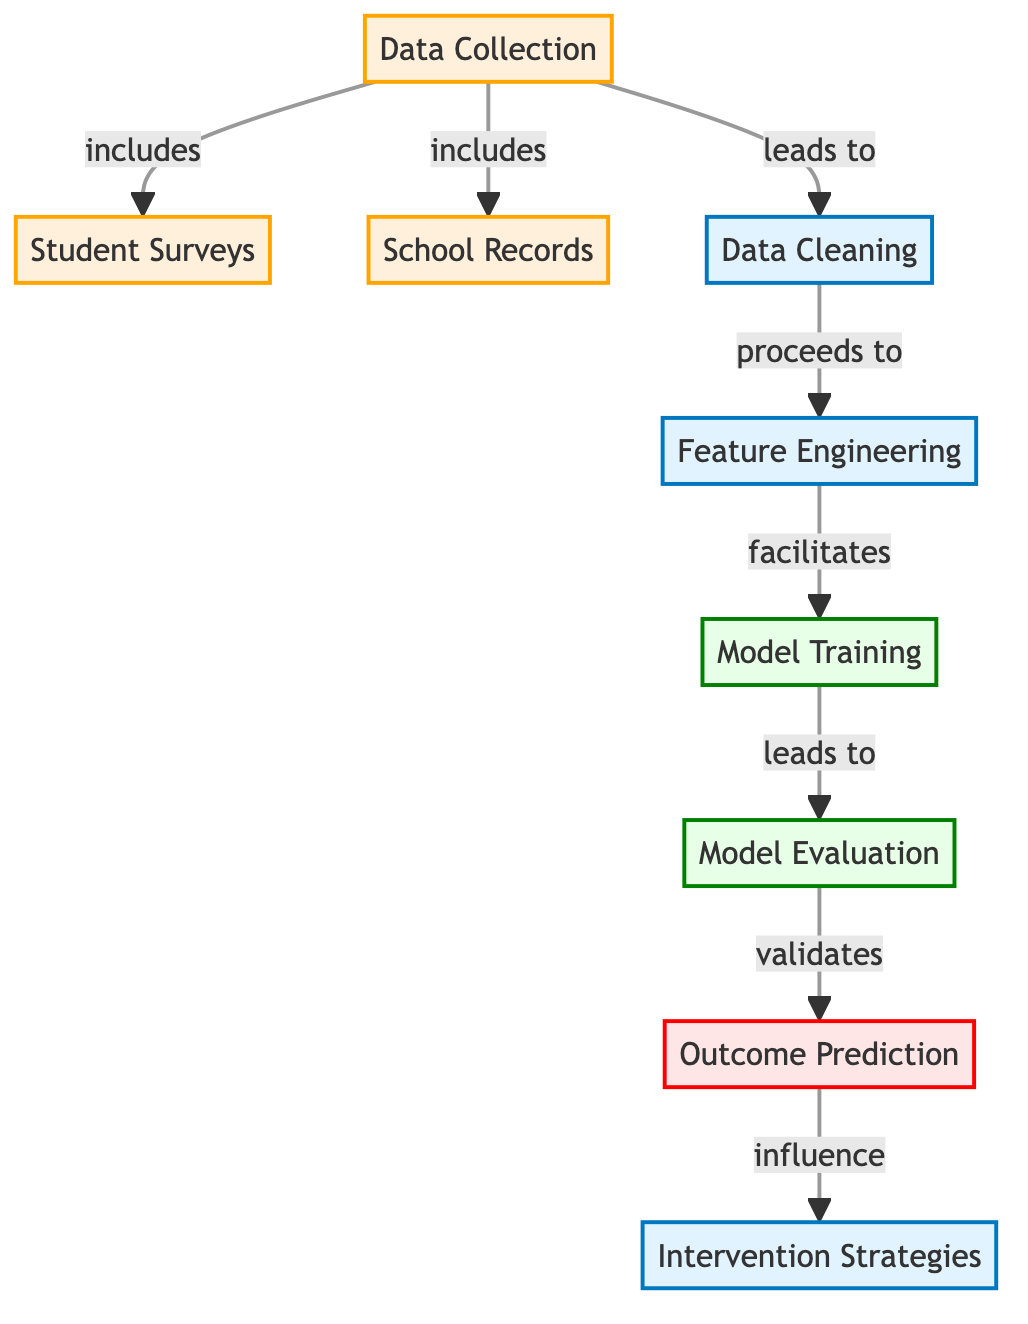What are the two types of data sources mentioned in the diagram? The diagram lists two data sources: "Student Surveys" and "School Records" as part of the "Data Collection" process.
Answer: Student Surveys, School Records How does Data Cleaning relate to Feature Engineering in the process? The diagram shows that "Data Cleaning" leads to "Feature Engineering", indicating that data must be cleaned before features are engineered.
Answer: Leads to What is the output of the "Model Evaluation" step? The output of the "Model Evaluation" step is the "Outcome Prediction", which follows after model evaluation is completed.
Answer: Outcome Prediction How many main processes are involved in this machine learning workflow? There are four main process nodes in the machine learning workflow: "Data Cleaning," "Feature Engineering," "Model Training," and "Model Evaluation."
Answer: Four What influences "Intervention Strategies" according to the diagram? The diagram indicates that "Outcome Prediction" influences "Intervention Strategies," meaning that the predictions made help shape intervention efforts.
Answer: Outcome Prediction Which node precedes "Model Training"? The node that precedes "Model Training" is "Feature Engineering," showing the order of operations in the workflow.
Answer: Feature Engineering What type of data is represented by the "Student Surveys" and "School Records"? Both "Student Surveys" and "School Records" are classified under the "data" category in the diagram, indicating they are sources of input data.
Answer: Data How does the information flow from "Data Collection" to "Intervention Strategies"? The flow is sequential: "Data Collection" leads to "Data Cleaning," then to "Feature Engineering," followed by "Model Training," "Model Evaluation," and finally results in "Outcome Prediction," which influences "Intervention Strategies."
Answer: Sequential flow What is the purpose of "Feature Engineering" in this workflow? "Feature Engineering" is a process that facilitates creating features from the cleaned data which are critical for training the model effectively.
Answer: Facilitates 